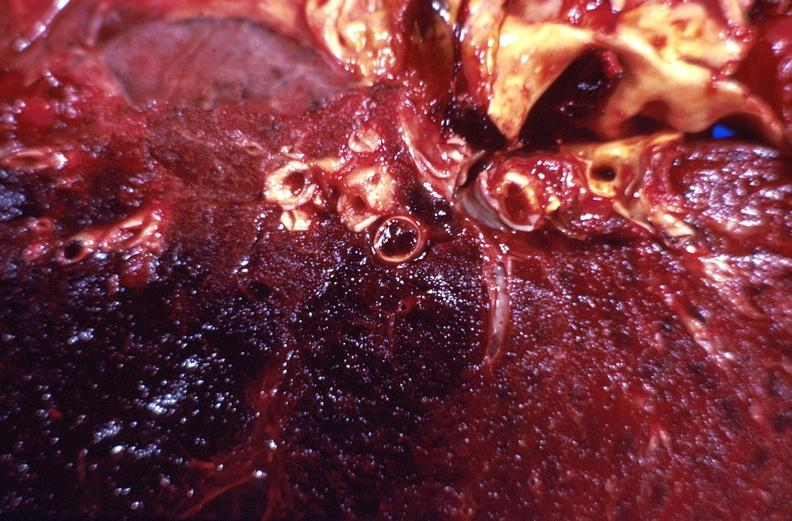where is this?
Answer the question using a single word or phrase. Lung 